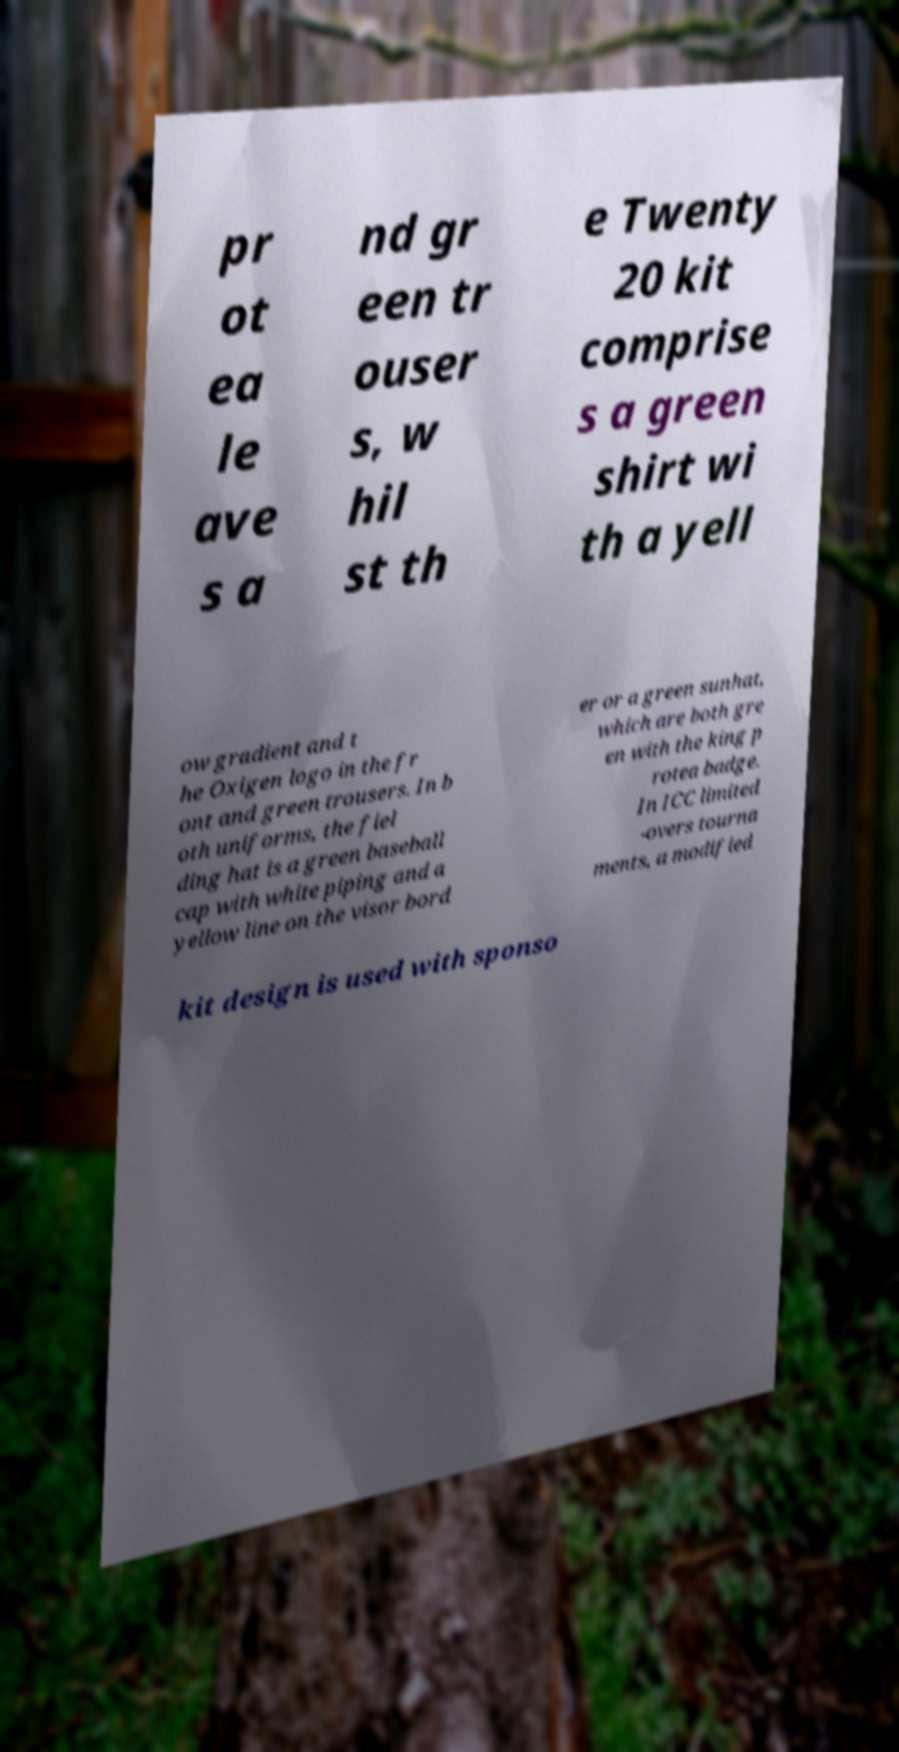I need the written content from this picture converted into text. Can you do that? pr ot ea le ave s a nd gr een tr ouser s, w hil st th e Twenty 20 kit comprise s a green shirt wi th a yell ow gradient and t he Oxigen logo in the fr ont and green trousers. In b oth uniforms, the fiel ding hat is a green baseball cap with white piping and a yellow line on the visor bord er or a green sunhat, which are both gre en with the king p rotea badge. In ICC limited -overs tourna ments, a modified kit design is used with sponso 